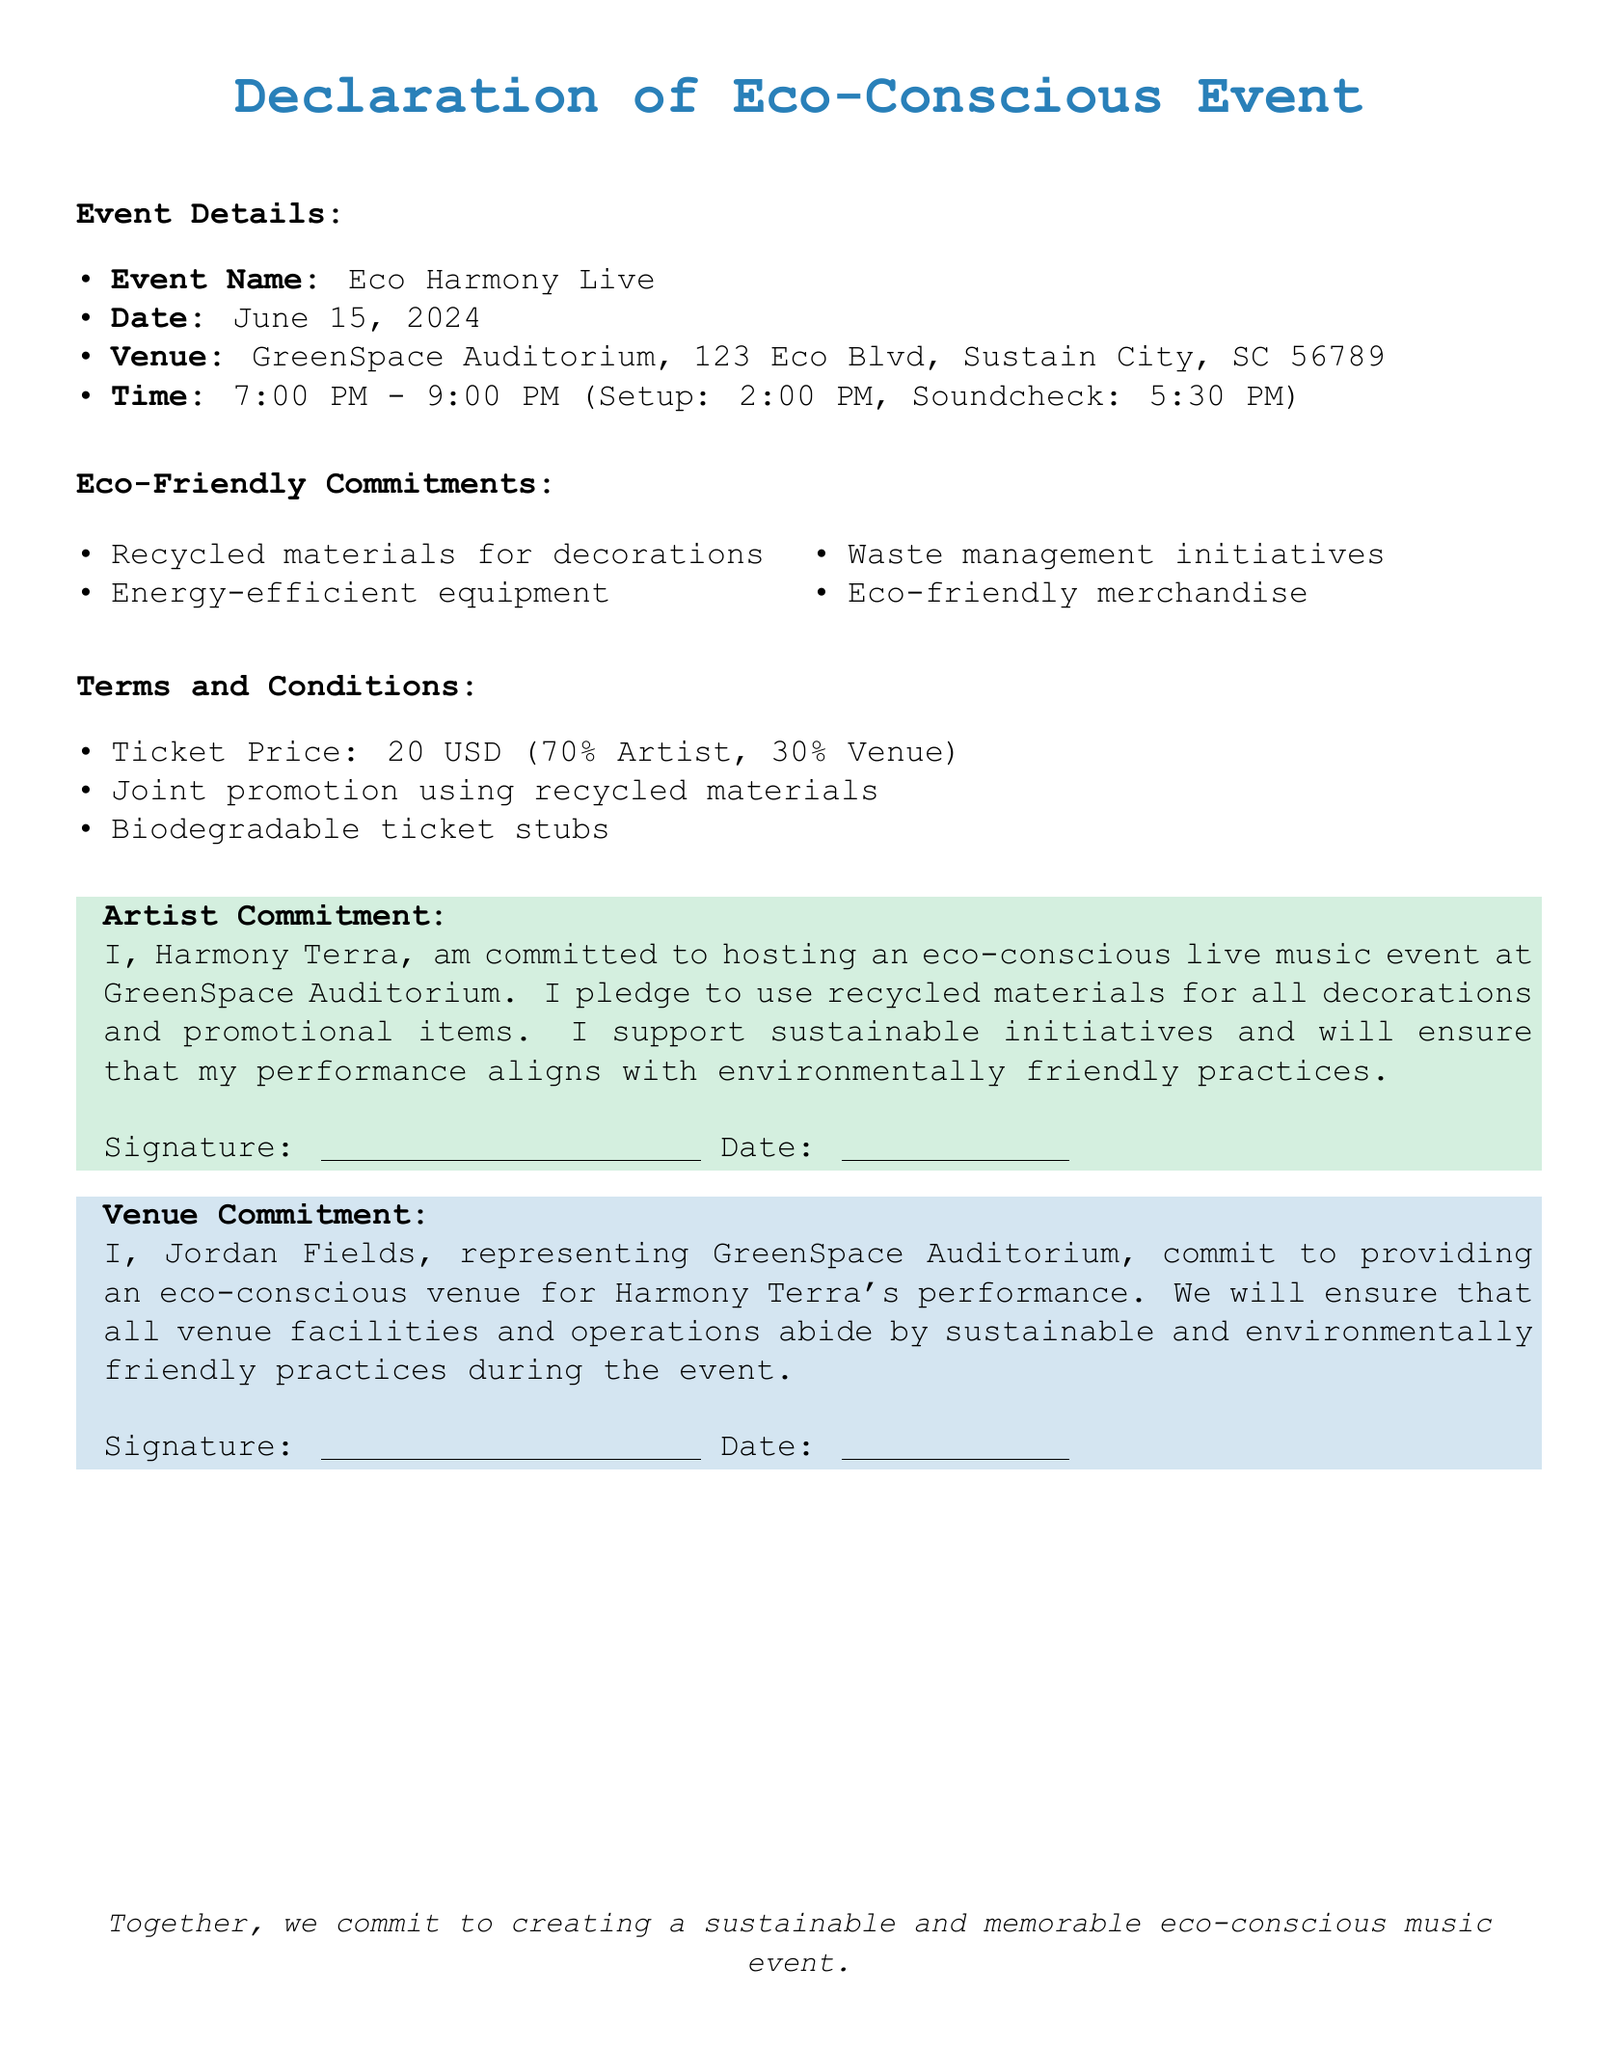what is the event name? The event name is specified under Event Details in the document.
Answer: Eco Harmony Live what is the date of the event? The date of the event is mentioned in the Event Details section.
Answer: June 15, 2024 where is the venue located? The venue location is provided in the Event Details section of the document.
Answer: GreenSpace Auditorium, 123 Eco Blvd, Sustain City, SC 56789 what percentage of ticket sales goes to the artist? This percentage is specified in the Terms and Conditions section regarding ticket distribution.
Answer: 70% who is the artist committing to the eco-conscious event? The artist's name is mentioned in the Artist Commitment section.
Answer: Harmony Terra what type of materials will be used for decorations? The type of materials for decorations is stated in the Eco-Friendly Commitments section.
Answer: Recycled materials what kind of ticket stubs will be used? The type of ticket stubs is described in the Terms and Conditions section of the document.
Answer: Biodegradable ticket stubs who represents the venue in this agreement? The representative of the venue is mentioned in the Venue Commitment section.
Answer: Jordan Fields what time does the event start? The starting time of the event is indicated in the Event Details section.
Answer: 7:00 PM 